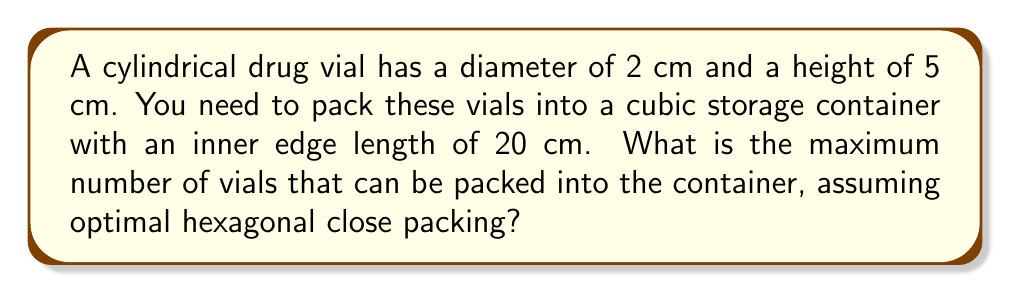Can you solve this math problem? To solve this problem, we'll follow these steps:

1. Calculate the volume of a single vial:
   $$V_{vial} = \pi r^2 h = \pi (1 \text{ cm})^2 (5 \text{ cm}) = 5\pi \text{ cm}^3$$

2. Calculate the volume of the cubic container:
   $$V_{container} = 20 \text{ cm} \times 20 \text{ cm} \times 20 \text{ cm} = 8000 \text{ cm}^3$$

3. Determine the packing density for hexagonal close packing of cylinders:
   The theoretical maximum packing density for cylinders is $\frac{\pi}{2\sqrt{3}} \approx 0.9069$

4. Calculate the effective volume occupied by the vials:
   $$V_{effective} = 8000 \text{ cm}^3 \times 0.9069 = 7255.2 \text{ cm}^3$$

5. Calculate the number of vials that can be packed:
   $$N = \frac{V_{effective}}{V_{vial}} = \frac{7255.2 \text{ cm}^3}{5\pi \text{ cm}^3} \approx 461.27$$

6. Round down to the nearest whole number, as we can't have partial vials:
   $$N = 461 \text{ vials}$$

[asy]
import three;

size(200);
currentprojection=perspective(6,3,2);

// Draw the cube
draw(box((0,0,0),(20,20,20)));

// Draw some cylinders to represent vials
for(int i=0; i<4; ++i) {
  for(int j=0; j<4; ++j) {
    draw(cylinder((2+4*i,2+4*j,0),1,5));
  }
}

// Label
label("20 cm", (10,20,0), S);
label("2 cm", (2,2,5), N);
label("5 cm", (0,0,2.5), W);
[/asy]
Answer: 461 vials 